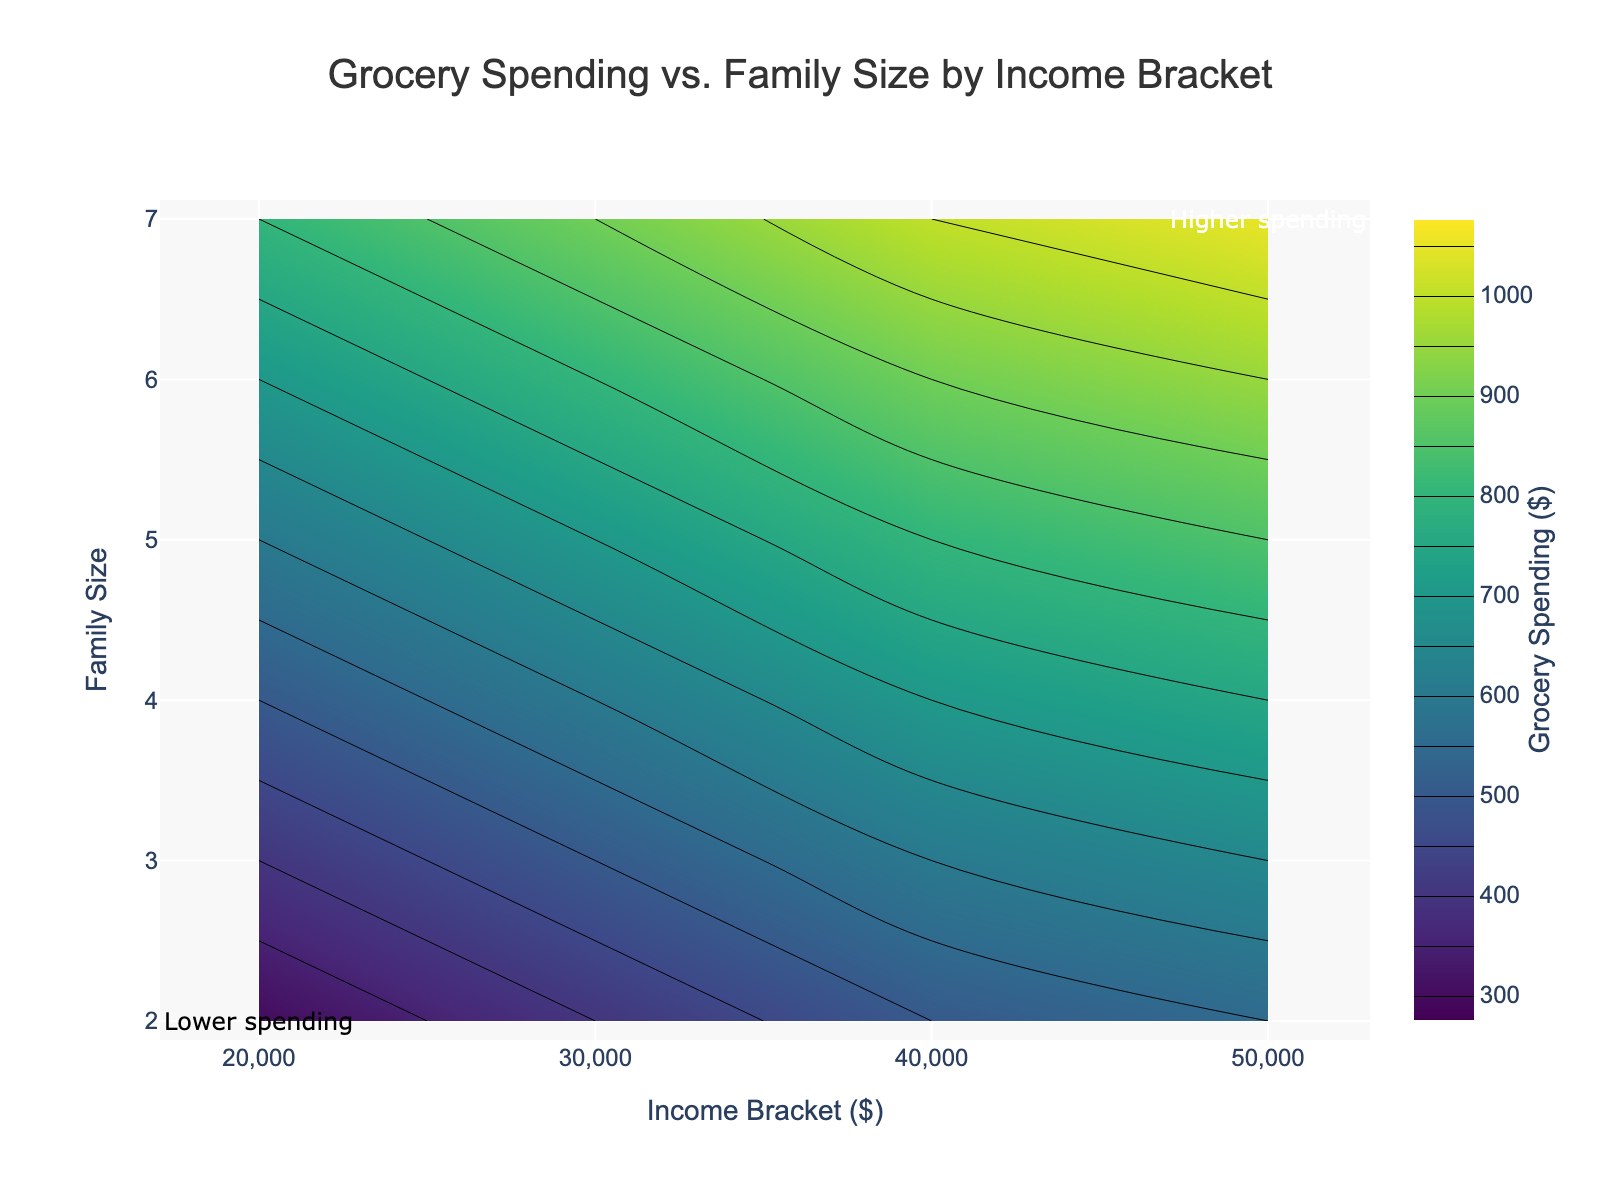Which income bracket has the highest grocery spending for a family size of 4? Look at the contour plot and find the income bracket where the family size is 4 and grocery spending is the highest. The highest spending contour for family size 4 is around $50,000.
Answer: 50,000 What is the range of grocery spending for a family size of 6? Identify the grocery spending values at the contours for a family size of 6. The lowest spending is around $700 and the highest is $950. So the range is $950 - $700.
Answer: $250 Which family size has the highest grocery spending for an income of $30,000? Check the contour lines corresponding to the $30,000 income bracket and see which family size intersects with the highest spending value. The highest spending at $30,000 intersects with family size 7.
Answer: 7 How does grocery spending change as family size increases for an income bracket of $20,000? Trace the contours at the $20,000 income bracket across family sizes. Grocery spending increases steadily from $300 (family size 2) to $800 (family size 7).
Answer: It increases For a family size of 5, what is the difference in grocery spending between the $40,000 and $50,000 income brackets? Identify the contour lines for a family size of 5 at $40,000 and $50,000 income brackets. The spending is $800 at $40,000 and $850 at $50,000. The difference is $850 - $800.
Answer: $50 In which income bracket does grocery spending surpass $900 for the first time for a family size of 6? Examine the contours for a family size of 6 to find where the spending first exceeds $900. The contour exceeds $900 at the $40,000 income bracket.
Answer: 40,000 Is there a consistent increase in grocery spending across all income brackets as family size increases from 2 to 7? By observing the contour lines, you can see if grocery spending consistently increases as family size increases from 2 to 7 across different income brackets. The spending does consistently increase as family size grows.
Answer: Yes What is the contour color associated with the highest grocery spending? The color representing the highest grocery spending on the Viridis color scale can be seen for spending values around $1050. The color is yellowish-green.
Answer: Yellowish-green For a family of size 3, how much more are they spending on groceries at the $50,000 income bracket compared to the $20,000 income bracket? Look at the contour values for a family size of 3 at both $50,000 and $20,000 income brackets. Spending is $650 at $50,000 and $400 at $20,000. The difference is $650 - $400.
Answer: $250 